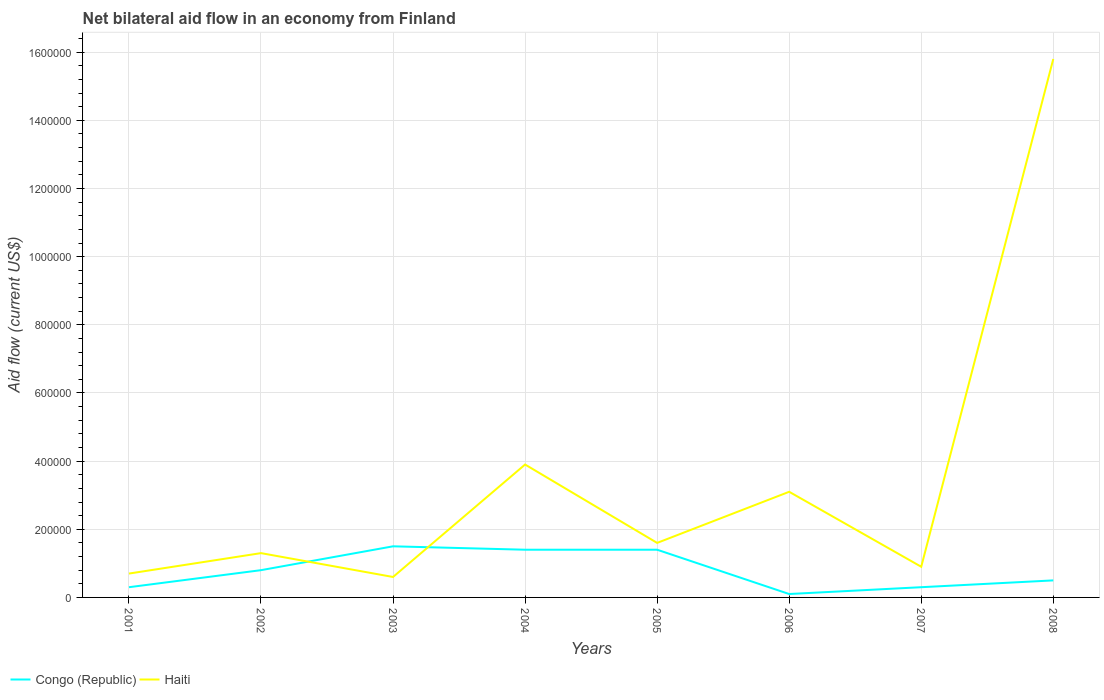How many different coloured lines are there?
Provide a short and direct response. 2. Does the line corresponding to Haiti intersect with the line corresponding to Congo (Republic)?
Make the answer very short. Yes. In which year was the net bilateral aid flow in Congo (Republic) maximum?
Offer a terse response. 2006. What is the total net bilateral aid flow in Congo (Republic) in the graph?
Your answer should be very brief. -2.00e+04. What is the difference between the highest and the second highest net bilateral aid flow in Haiti?
Keep it short and to the point. 1.52e+06. What is the difference between two consecutive major ticks on the Y-axis?
Make the answer very short. 2.00e+05. Are the values on the major ticks of Y-axis written in scientific E-notation?
Provide a short and direct response. No. Where does the legend appear in the graph?
Offer a terse response. Bottom left. How are the legend labels stacked?
Offer a terse response. Horizontal. What is the title of the graph?
Offer a terse response. Net bilateral aid flow in an economy from Finland. What is the Aid flow (current US$) in Haiti in 2001?
Your answer should be compact. 7.00e+04. What is the Aid flow (current US$) in Congo (Republic) in 2002?
Give a very brief answer. 8.00e+04. What is the Aid flow (current US$) of Congo (Republic) in 2003?
Keep it short and to the point. 1.50e+05. What is the Aid flow (current US$) of Congo (Republic) in 2005?
Give a very brief answer. 1.40e+05. What is the Aid flow (current US$) in Haiti in 2005?
Your response must be concise. 1.60e+05. What is the Aid flow (current US$) in Congo (Republic) in 2007?
Ensure brevity in your answer.  3.00e+04. What is the Aid flow (current US$) in Haiti in 2007?
Give a very brief answer. 9.00e+04. What is the Aid flow (current US$) in Haiti in 2008?
Provide a succinct answer. 1.58e+06. Across all years, what is the maximum Aid flow (current US$) of Haiti?
Provide a succinct answer. 1.58e+06. Across all years, what is the minimum Aid flow (current US$) of Congo (Republic)?
Your answer should be very brief. 10000. What is the total Aid flow (current US$) in Congo (Republic) in the graph?
Offer a very short reply. 6.30e+05. What is the total Aid flow (current US$) of Haiti in the graph?
Make the answer very short. 2.79e+06. What is the difference between the Aid flow (current US$) in Congo (Republic) in 2001 and that in 2002?
Your answer should be compact. -5.00e+04. What is the difference between the Aid flow (current US$) of Congo (Republic) in 2001 and that in 2003?
Give a very brief answer. -1.20e+05. What is the difference between the Aid flow (current US$) in Haiti in 2001 and that in 2004?
Ensure brevity in your answer.  -3.20e+05. What is the difference between the Aid flow (current US$) of Haiti in 2001 and that in 2006?
Give a very brief answer. -2.40e+05. What is the difference between the Aid flow (current US$) in Congo (Republic) in 2001 and that in 2007?
Offer a terse response. 0. What is the difference between the Aid flow (current US$) in Haiti in 2001 and that in 2008?
Provide a short and direct response. -1.51e+06. What is the difference between the Aid flow (current US$) of Haiti in 2002 and that in 2004?
Keep it short and to the point. -2.60e+05. What is the difference between the Aid flow (current US$) of Haiti in 2002 and that in 2005?
Keep it short and to the point. -3.00e+04. What is the difference between the Aid flow (current US$) in Congo (Republic) in 2002 and that in 2006?
Provide a succinct answer. 7.00e+04. What is the difference between the Aid flow (current US$) in Congo (Republic) in 2002 and that in 2007?
Ensure brevity in your answer.  5.00e+04. What is the difference between the Aid flow (current US$) of Congo (Republic) in 2002 and that in 2008?
Your answer should be very brief. 3.00e+04. What is the difference between the Aid flow (current US$) of Haiti in 2002 and that in 2008?
Your answer should be compact. -1.45e+06. What is the difference between the Aid flow (current US$) in Congo (Republic) in 2003 and that in 2004?
Your answer should be very brief. 10000. What is the difference between the Aid flow (current US$) in Haiti in 2003 and that in 2004?
Your answer should be very brief. -3.30e+05. What is the difference between the Aid flow (current US$) in Congo (Republic) in 2003 and that in 2008?
Your answer should be very brief. 1.00e+05. What is the difference between the Aid flow (current US$) of Haiti in 2003 and that in 2008?
Keep it short and to the point. -1.52e+06. What is the difference between the Aid flow (current US$) in Haiti in 2004 and that in 2006?
Make the answer very short. 8.00e+04. What is the difference between the Aid flow (current US$) in Haiti in 2004 and that in 2007?
Your answer should be compact. 3.00e+05. What is the difference between the Aid flow (current US$) in Congo (Republic) in 2004 and that in 2008?
Your answer should be very brief. 9.00e+04. What is the difference between the Aid flow (current US$) in Haiti in 2004 and that in 2008?
Provide a short and direct response. -1.19e+06. What is the difference between the Aid flow (current US$) of Congo (Republic) in 2005 and that in 2006?
Give a very brief answer. 1.30e+05. What is the difference between the Aid flow (current US$) in Haiti in 2005 and that in 2007?
Keep it short and to the point. 7.00e+04. What is the difference between the Aid flow (current US$) in Congo (Republic) in 2005 and that in 2008?
Keep it short and to the point. 9.00e+04. What is the difference between the Aid flow (current US$) of Haiti in 2005 and that in 2008?
Ensure brevity in your answer.  -1.42e+06. What is the difference between the Aid flow (current US$) of Haiti in 2006 and that in 2008?
Your answer should be very brief. -1.27e+06. What is the difference between the Aid flow (current US$) of Haiti in 2007 and that in 2008?
Offer a terse response. -1.49e+06. What is the difference between the Aid flow (current US$) in Congo (Republic) in 2001 and the Aid flow (current US$) in Haiti in 2003?
Make the answer very short. -3.00e+04. What is the difference between the Aid flow (current US$) in Congo (Republic) in 2001 and the Aid flow (current US$) in Haiti in 2004?
Offer a very short reply. -3.60e+05. What is the difference between the Aid flow (current US$) in Congo (Republic) in 2001 and the Aid flow (current US$) in Haiti in 2006?
Offer a very short reply. -2.80e+05. What is the difference between the Aid flow (current US$) in Congo (Republic) in 2001 and the Aid flow (current US$) in Haiti in 2007?
Keep it short and to the point. -6.00e+04. What is the difference between the Aid flow (current US$) of Congo (Republic) in 2001 and the Aid flow (current US$) of Haiti in 2008?
Give a very brief answer. -1.55e+06. What is the difference between the Aid flow (current US$) in Congo (Republic) in 2002 and the Aid flow (current US$) in Haiti in 2003?
Your answer should be very brief. 2.00e+04. What is the difference between the Aid flow (current US$) of Congo (Republic) in 2002 and the Aid flow (current US$) of Haiti in 2004?
Your answer should be very brief. -3.10e+05. What is the difference between the Aid flow (current US$) in Congo (Republic) in 2002 and the Aid flow (current US$) in Haiti in 2005?
Provide a short and direct response. -8.00e+04. What is the difference between the Aid flow (current US$) in Congo (Republic) in 2002 and the Aid flow (current US$) in Haiti in 2006?
Your answer should be very brief. -2.30e+05. What is the difference between the Aid flow (current US$) in Congo (Republic) in 2002 and the Aid flow (current US$) in Haiti in 2007?
Offer a terse response. -10000. What is the difference between the Aid flow (current US$) in Congo (Republic) in 2002 and the Aid flow (current US$) in Haiti in 2008?
Make the answer very short. -1.50e+06. What is the difference between the Aid flow (current US$) of Congo (Republic) in 2003 and the Aid flow (current US$) of Haiti in 2004?
Your answer should be compact. -2.40e+05. What is the difference between the Aid flow (current US$) of Congo (Republic) in 2003 and the Aid flow (current US$) of Haiti in 2006?
Make the answer very short. -1.60e+05. What is the difference between the Aid flow (current US$) in Congo (Republic) in 2003 and the Aid flow (current US$) in Haiti in 2008?
Your response must be concise. -1.43e+06. What is the difference between the Aid flow (current US$) of Congo (Republic) in 2004 and the Aid flow (current US$) of Haiti in 2005?
Ensure brevity in your answer.  -2.00e+04. What is the difference between the Aid flow (current US$) in Congo (Republic) in 2004 and the Aid flow (current US$) in Haiti in 2006?
Provide a short and direct response. -1.70e+05. What is the difference between the Aid flow (current US$) in Congo (Republic) in 2004 and the Aid flow (current US$) in Haiti in 2007?
Ensure brevity in your answer.  5.00e+04. What is the difference between the Aid flow (current US$) in Congo (Republic) in 2004 and the Aid flow (current US$) in Haiti in 2008?
Ensure brevity in your answer.  -1.44e+06. What is the difference between the Aid flow (current US$) of Congo (Republic) in 2005 and the Aid flow (current US$) of Haiti in 2007?
Offer a very short reply. 5.00e+04. What is the difference between the Aid flow (current US$) in Congo (Republic) in 2005 and the Aid flow (current US$) in Haiti in 2008?
Offer a terse response. -1.44e+06. What is the difference between the Aid flow (current US$) of Congo (Republic) in 2006 and the Aid flow (current US$) of Haiti in 2008?
Provide a succinct answer. -1.57e+06. What is the difference between the Aid flow (current US$) of Congo (Republic) in 2007 and the Aid flow (current US$) of Haiti in 2008?
Give a very brief answer. -1.55e+06. What is the average Aid flow (current US$) of Congo (Republic) per year?
Offer a very short reply. 7.88e+04. What is the average Aid flow (current US$) in Haiti per year?
Provide a succinct answer. 3.49e+05. In the year 2002, what is the difference between the Aid flow (current US$) of Congo (Republic) and Aid flow (current US$) of Haiti?
Keep it short and to the point. -5.00e+04. In the year 2003, what is the difference between the Aid flow (current US$) in Congo (Republic) and Aid flow (current US$) in Haiti?
Make the answer very short. 9.00e+04. In the year 2004, what is the difference between the Aid flow (current US$) of Congo (Republic) and Aid flow (current US$) of Haiti?
Your answer should be very brief. -2.50e+05. In the year 2005, what is the difference between the Aid flow (current US$) in Congo (Republic) and Aid flow (current US$) in Haiti?
Ensure brevity in your answer.  -2.00e+04. In the year 2006, what is the difference between the Aid flow (current US$) in Congo (Republic) and Aid flow (current US$) in Haiti?
Ensure brevity in your answer.  -3.00e+05. In the year 2008, what is the difference between the Aid flow (current US$) of Congo (Republic) and Aid flow (current US$) of Haiti?
Offer a very short reply. -1.53e+06. What is the ratio of the Aid flow (current US$) of Congo (Republic) in 2001 to that in 2002?
Provide a short and direct response. 0.38. What is the ratio of the Aid flow (current US$) in Haiti in 2001 to that in 2002?
Your answer should be very brief. 0.54. What is the ratio of the Aid flow (current US$) of Congo (Republic) in 2001 to that in 2003?
Your answer should be compact. 0.2. What is the ratio of the Aid flow (current US$) of Haiti in 2001 to that in 2003?
Give a very brief answer. 1.17. What is the ratio of the Aid flow (current US$) of Congo (Republic) in 2001 to that in 2004?
Offer a terse response. 0.21. What is the ratio of the Aid flow (current US$) in Haiti in 2001 to that in 2004?
Your answer should be very brief. 0.18. What is the ratio of the Aid flow (current US$) in Congo (Republic) in 2001 to that in 2005?
Offer a very short reply. 0.21. What is the ratio of the Aid flow (current US$) of Haiti in 2001 to that in 2005?
Offer a terse response. 0.44. What is the ratio of the Aid flow (current US$) in Haiti in 2001 to that in 2006?
Ensure brevity in your answer.  0.23. What is the ratio of the Aid flow (current US$) in Haiti in 2001 to that in 2007?
Your answer should be very brief. 0.78. What is the ratio of the Aid flow (current US$) of Congo (Republic) in 2001 to that in 2008?
Offer a terse response. 0.6. What is the ratio of the Aid flow (current US$) of Haiti in 2001 to that in 2008?
Give a very brief answer. 0.04. What is the ratio of the Aid flow (current US$) of Congo (Republic) in 2002 to that in 2003?
Make the answer very short. 0.53. What is the ratio of the Aid flow (current US$) in Haiti in 2002 to that in 2003?
Offer a very short reply. 2.17. What is the ratio of the Aid flow (current US$) of Haiti in 2002 to that in 2004?
Your answer should be very brief. 0.33. What is the ratio of the Aid flow (current US$) in Congo (Republic) in 2002 to that in 2005?
Give a very brief answer. 0.57. What is the ratio of the Aid flow (current US$) in Haiti in 2002 to that in 2005?
Provide a succinct answer. 0.81. What is the ratio of the Aid flow (current US$) in Congo (Republic) in 2002 to that in 2006?
Your answer should be very brief. 8. What is the ratio of the Aid flow (current US$) of Haiti in 2002 to that in 2006?
Give a very brief answer. 0.42. What is the ratio of the Aid flow (current US$) in Congo (Republic) in 2002 to that in 2007?
Your answer should be compact. 2.67. What is the ratio of the Aid flow (current US$) of Haiti in 2002 to that in 2007?
Make the answer very short. 1.44. What is the ratio of the Aid flow (current US$) of Haiti in 2002 to that in 2008?
Your response must be concise. 0.08. What is the ratio of the Aid flow (current US$) in Congo (Republic) in 2003 to that in 2004?
Your answer should be very brief. 1.07. What is the ratio of the Aid flow (current US$) in Haiti in 2003 to that in 2004?
Make the answer very short. 0.15. What is the ratio of the Aid flow (current US$) of Congo (Republic) in 2003 to that in 2005?
Ensure brevity in your answer.  1.07. What is the ratio of the Aid flow (current US$) of Haiti in 2003 to that in 2005?
Your response must be concise. 0.38. What is the ratio of the Aid flow (current US$) in Congo (Republic) in 2003 to that in 2006?
Your answer should be very brief. 15. What is the ratio of the Aid flow (current US$) in Haiti in 2003 to that in 2006?
Provide a short and direct response. 0.19. What is the ratio of the Aid flow (current US$) in Haiti in 2003 to that in 2007?
Ensure brevity in your answer.  0.67. What is the ratio of the Aid flow (current US$) in Haiti in 2003 to that in 2008?
Offer a very short reply. 0.04. What is the ratio of the Aid flow (current US$) in Congo (Republic) in 2004 to that in 2005?
Provide a short and direct response. 1. What is the ratio of the Aid flow (current US$) in Haiti in 2004 to that in 2005?
Offer a terse response. 2.44. What is the ratio of the Aid flow (current US$) of Haiti in 2004 to that in 2006?
Give a very brief answer. 1.26. What is the ratio of the Aid flow (current US$) in Congo (Republic) in 2004 to that in 2007?
Provide a short and direct response. 4.67. What is the ratio of the Aid flow (current US$) in Haiti in 2004 to that in 2007?
Your response must be concise. 4.33. What is the ratio of the Aid flow (current US$) in Congo (Republic) in 2004 to that in 2008?
Your answer should be very brief. 2.8. What is the ratio of the Aid flow (current US$) of Haiti in 2004 to that in 2008?
Provide a succinct answer. 0.25. What is the ratio of the Aid flow (current US$) of Congo (Republic) in 2005 to that in 2006?
Your answer should be compact. 14. What is the ratio of the Aid flow (current US$) in Haiti in 2005 to that in 2006?
Give a very brief answer. 0.52. What is the ratio of the Aid flow (current US$) in Congo (Republic) in 2005 to that in 2007?
Provide a succinct answer. 4.67. What is the ratio of the Aid flow (current US$) in Haiti in 2005 to that in 2007?
Give a very brief answer. 1.78. What is the ratio of the Aid flow (current US$) in Congo (Republic) in 2005 to that in 2008?
Give a very brief answer. 2.8. What is the ratio of the Aid flow (current US$) in Haiti in 2005 to that in 2008?
Make the answer very short. 0.1. What is the ratio of the Aid flow (current US$) of Haiti in 2006 to that in 2007?
Offer a terse response. 3.44. What is the ratio of the Aid flow (current US$) in Haiti in 2006 to that in 2008?
Keep it short and to the point. 0.2. What is the ratio of the Aid flow (current US$) in Haiti in 2007 to that in 2008?
Offer a very short reply. 0.06. What is the difference between the highest and the second highest Aid flow (current US$) in Haiti?
Keep it short and to the point. 1.19e+06. What is the difference between the highest and the lowest Aid flow (current US$) of Congo (Republic)?
Your response must be concise. 1.40e+05. What is the difference between the highest and the lowest Aid flow (current US$) of Haiti?
Make the answer very short. 1.52e+06. 